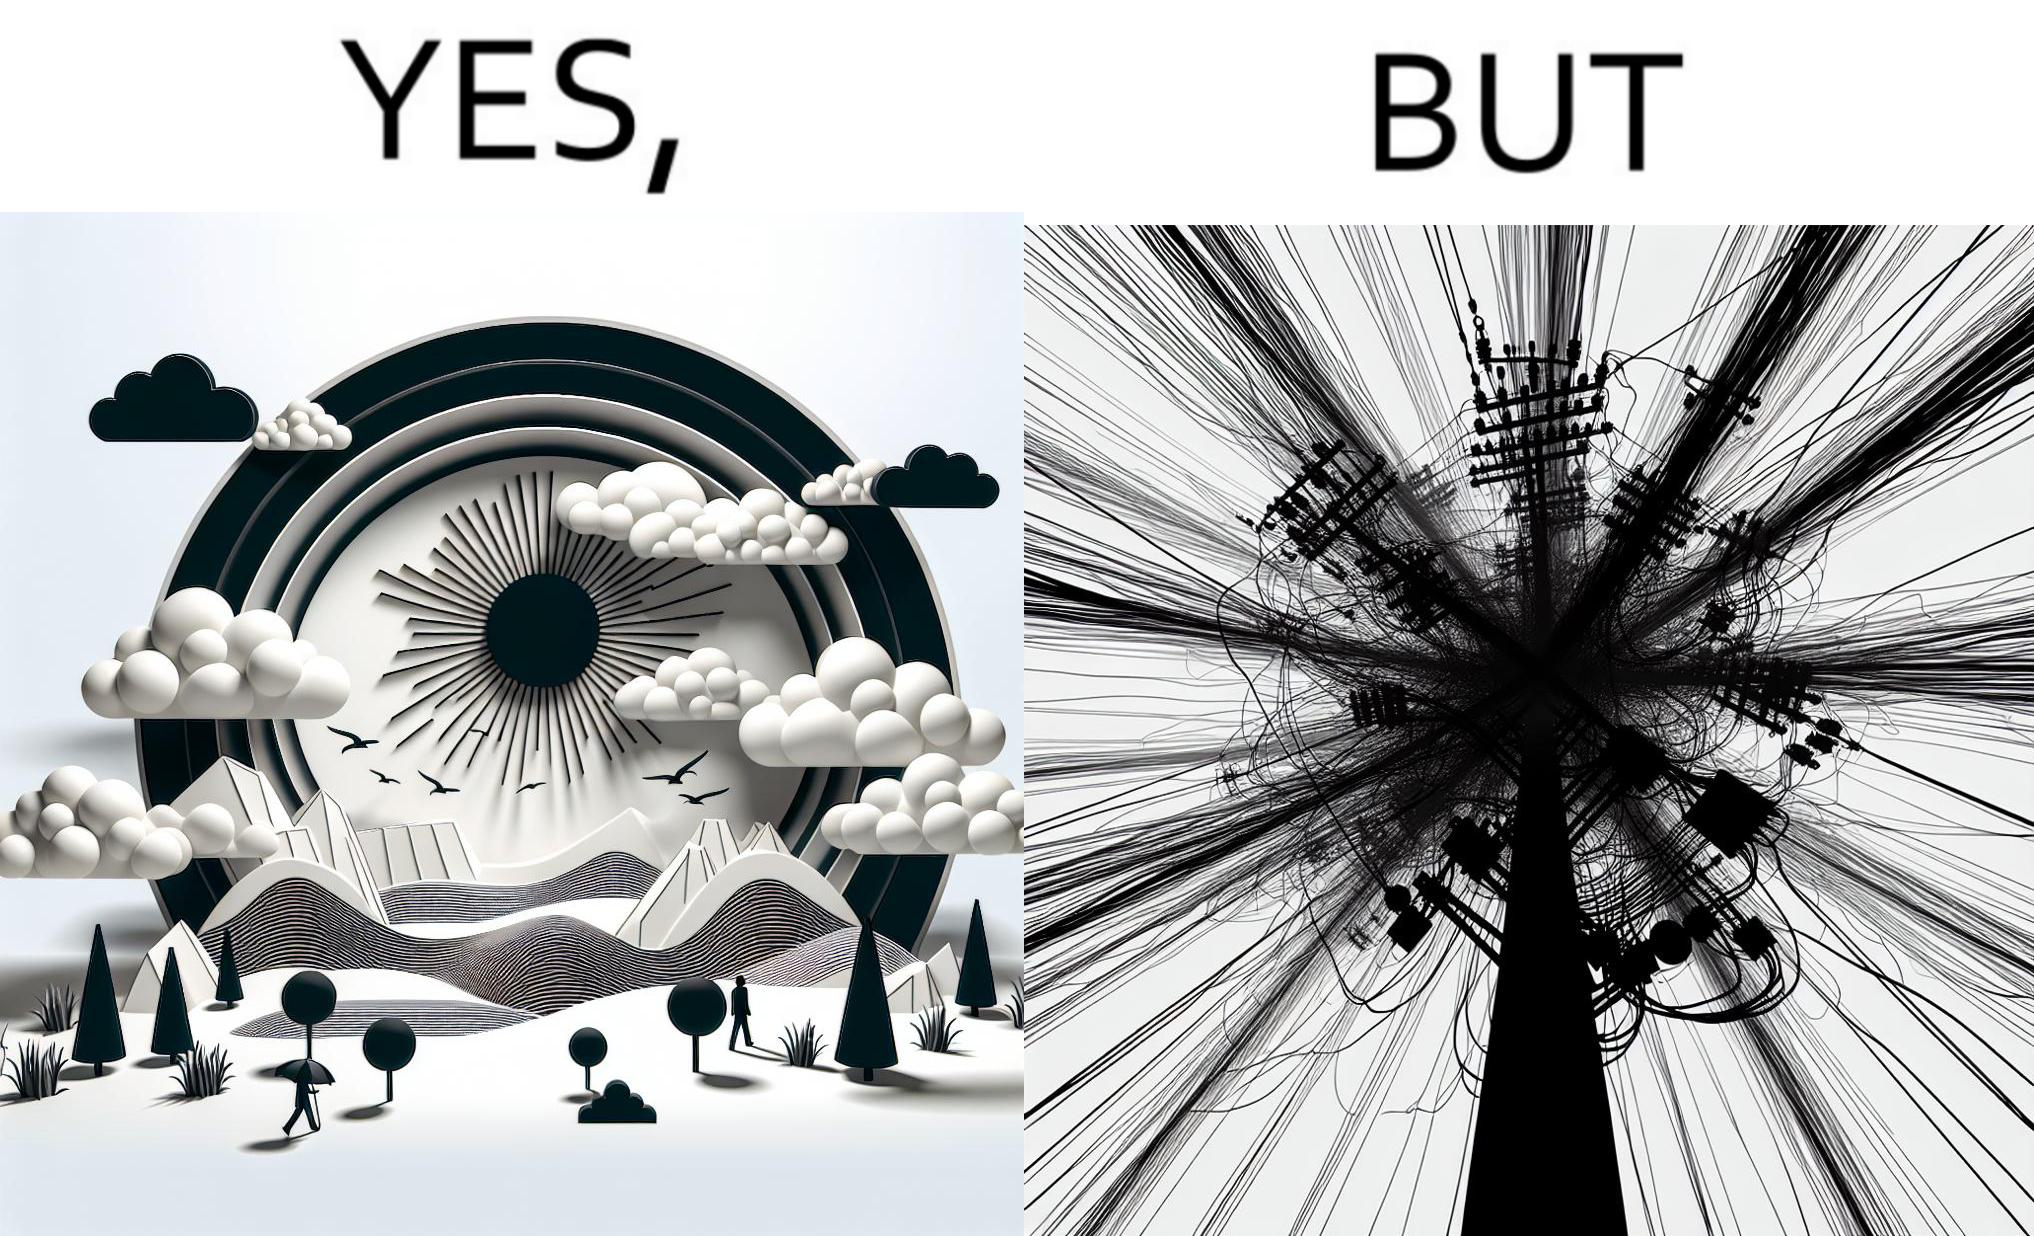Describe the contrast between the left and right parts of this image. In the left part of the image: a clear sky with sun and clouds In the right part of the image: an electricity pole with a lot of wires over it 